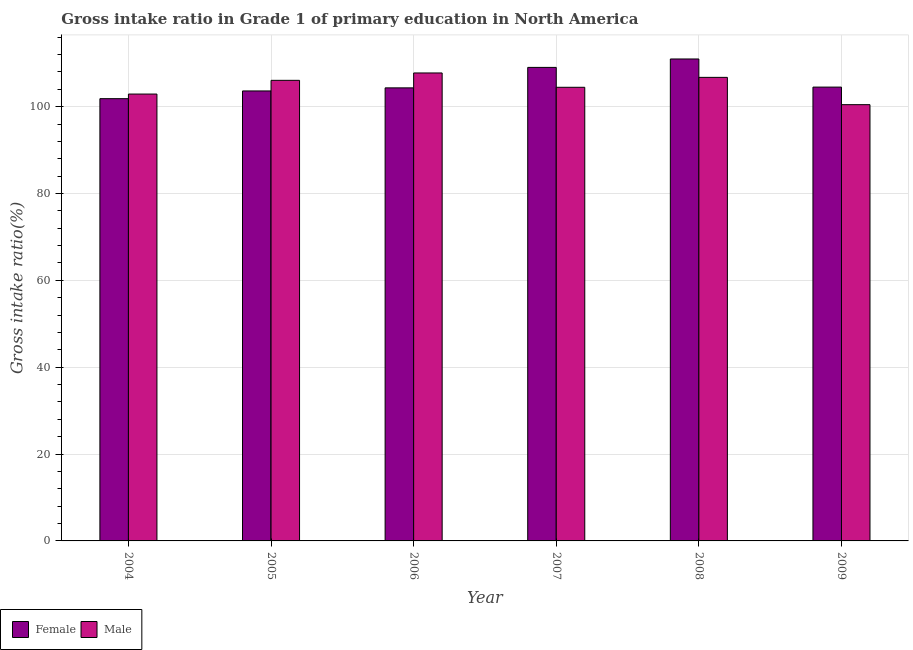Are the number of bars per tick equal to the number of legend labels?
Your answer should be very brief. Yes. Are the number of bars on each tick of the X-axis equal?
Make the answer very short. Yes. How many bars are there on the 6th tick from the left?
Offer a terse response. 2. How many bars are there on the 1st tick from the right?
Your answer should be very brief. 2. What is the gross intake ratio(female) in 2006?
Your answer should be compact. 104.33. Across all years, what is the maximum gross intake ratio(male)?
Provide a succinct answer. 107.76. Across all years, what is the minimum gross intake ratio(male)?
Your answer should be compact. 100.46. In which year was the gross intake ratio(female) minimum?
Make the answer very short. 2004. What is the total gross intake ratio(female) in the graph?
Give a very brief answer. 634.32. What is the difference between the gross intake ratio(female) in 2006 and that in 2007?
Your answer should be very brief. -4.71. What is the difference between the gross intake ratio(male) in 2009 and the gross intake ratio(female) in 2006?
Keep it short and to the point. -7.3. What is the average gross intake ratio(female) per year?
Ensure brevity in your answer.  105.72. In the year 2009, what is the difference between the gross intake ratio(female) and gross intake ratio(male)?
Provide a succinct answer. 0. What is the ratio of the gross intake ratio(female) in 2008 to that in 2009?
Keep it short and to the point. 1.06. Is the gross intake ratio(male) in 2005 less than that in 2008?
Offer a terse response. Yes. Is the difference between the gross intake ratio(male) in 2005 and 2007 greater than the difference between the gross intake ratio(female) in 2005 and 2007?
Make the answer very short. No. What is the difference between the highest and the second highest gross intake ratio(male)?
Offer a terse response. 1.01. What is the difference between the highest and the lowest gross intake ratio(male)?
Ensure brevity in your answer.  7.3. In how many years, is the gross intake ratio(male) greater than the average gross intake ratio(male) taken over all years?
Give a very brief answer. 3. What does the 1st bar from the left in 2008 represents?
Offer a very short reply. Female. What does the 1st bar from the right in 2005 represents?
Your answer should be very brief. Male. How many bars are there?
Offer a terse response. 12. What is the difference between two consecutive major ticks on the Y-axis?
Keep it short and to the point. 20. Are the values on the major ticks of Y-axis written in scientific E-notation?
Your response must be concise. No. Does the graph contain any zero values?
Your answer should be very brief. No. Does the graph contain grids?
Give a very brief answer. Yes. Where does the legend appear in the graph?
Your answer should be compact. Bottom left. How many legend labels are there?
Your answer should be compact. 2. What is the title of the graph?
Provide a short and direct response. Gross intake ratio in Grade 1 of primary education in North America. Does "Services" appear as one of the legend labels in the graph?
Your response must be concise. No. What is the label or title of the Y-axis?
Your answer should be compact. Gross intake ratio(%). What is the Gross intake ratio(%) of Female in 2004?
Make the answer very short. 101.84. What is the Gross intake ratio(%) of Male in 2004?
Offer a terse response. 102.9. What is the Gross intake ratio(%) of Female in 2005?
Provide a short and direct response. 103.62. What is the Gross intake ratio(%) in Male in 2005?
Provide a short and direct response. 106.07. What is the Gross intake ratio(%) of Female in 2006?
Provide a short and direct response. 104.33. What is the Gross intake ratio(%) of Male in 2006?
Your response must be concise. 107.76. What is the Gross intake ratio(%) in Female in 2007?
Offer a terse response. 109.04. What is the Gross intake ratio(%) of Male in 2007?
Your response must be concise. 104.46. What is the Gross intake ratio(%) of Female in 2008?
Ensure brevity in your answer.  110.98. What is the Gross intake ratio(%) in Male in 2008?
Your answer should be compact. 106.75. What is the Gross intake ratio(%) in Female in 2009?
Offer a very short reply. 104.5. What is the Gross intake ratio(%) in Male in 2009?
Provide a short and direct response. 100.46. Across all years, what is the maximum Gross intake ratio(%) in Female?
Provide a succinct answer. 110.98. Across all years, what is the maximum Gross intake ratio(%) of Male?
Your answer should be compact. 107.76. Across all years, what is the minimum Gross intake ratio(%) in Female?
Give a very brief answer. 101.84. Across all years, what is the minimum Gross intake ratio(%) of Male?
Your response must be concise. 100.46. What is the total Gross intake ratio(%) in Female in the graph?
Your answer should be compact. 634.32. What is the total Gross intake ratio(%) of Male in the graph?
Offer a terse response. 628.4. What is the difference between the Gross intake ratio(%) of Female in 2004 and that in 2005?
Provide a succinct answer. -1.78. What is the difference between the Gross intake ratio(%) of Male in 2004 and that in 2005?
Ensure brevity in your answer.  -3.16. What is the difference between the Gross intake ratio(%) in Female in 2004 and that in 2006?
Give a very brief answer. -2.49. What is the difference between the Gross intake ratio(%) in Male in 2004 and that in 2006?
Offer a very short reply. -4.86. What is the difference between the Gross intake ratio(%) in Female in 2004 and that in 2007?
Provide a short and direct response. -7.2. What is the difference between the Gross intake ratio(%) of Male in 2004 and that in 2007?
Provide a short and direct response. -1.56. What is the difference between the Gross intake ratio(%) in Female in 2004 and that in 2008?
Offer a terse response. -9.14. What is the difference between the Gross intake ratio(%) of Male in 2004 and that in 2008?
Provide a short and direct response. -3.84. What is the difference between the Gross intake ratio(%) of Female in 2004 and that in 2009?
Offer a terse response. -2.66. What is the difference between the Gross intake ratio(%) in Male in 2004 and that in 2009?
Provide a short and direct response. 2.44. What is the difference between the Gross intake ratio(%) in Female in 2005 and that in 2006?
Your answer should be very brief. -0.71. What is the difference between the Gross intake ratio(%) in Male in 2005 and that in 2006?
Make the answer very short. -1.7. What is the difference between the Gross intake ratio(%) in Female in 2005 and that in 2007?
Make the answer very short. -5.42. What is the difference between the Gross intake ratio(%) of Male in 2005 and that in 2007?
Your response must be concise. 1.6. What is the difference between the Gross intake ratio(%) of Female in 2005 and that in 2008?
Give a very brief answer. -7.36. What is the difference between the Gross intake ratio(%) in Male in 2005 and that in 2008?
Keep it short and to the point. -0.68. What is the difference between the Gross intake ratio(%) in Female in 2005 and that in 2009?
Provide a short and direct response. -0.88. What is the difference between the Gross intake ratio(%) of Male in 2005 and that in 2009?
Your answer should be compact. 5.6. What is the difference between the Gross intake ratio(%) of Female in 2006 and that in 2007?
Your answer should be very brief. -4.71. What is the difference between the Gross intake ratio(%) of Male in 2006 and that in 2007?
Offer a terse response. 3.3. What is the difference between the Gross intake ratio(%) in Female in 2006 and that in 2008?
Make the answer very short. -6.65. What is the difference between the Gross intake ratio(%) of Male in 2006 and that in 2008?
Offer a very short reply. 1.01. What is the difference between the Gross intake ratio(%) in Female in 2006 and that in 2009?
Offer a very short reply. -0.17. What is the difference between the Gross intake ratio(%) of Male in 2006 and that in 2009?
Give a very brief answer. 7.3. What is the difference between the Gross intake ratio(%) of Female in 2007 and that in 2008?
Provide a short and direct response. -1.94. What is the difference between the Gross intake ratio(%) in Male in 2007 and that in 2008?
Provide a succinct answer. -2.29. What is the difference between the Gross intake ratio(%) of Female in 2007 and that in 2009?
Offer a very short reply. 4.54. What is the difference between the Gross intake ratio(%) in Male in 2007 and that in 2009?
Make the answer very short. 4. What is the difference between the Gross intake ratio(%) in Female in 2008 and that in 2009?
Offer a very short reply. 6.48. What is the difference between the Gross intake ratio(%) in Male in 2008 and that in 2009?
Offer a terse response. 6.29. What is the difference between the Gross intake ratio(%) in Female in 2004 and the Gross intake ratio(%) in Male in 2005?
Keep it short and to the point. -4.22. What is the difference between the Gross intake ratio(%) of Female in 2004 and the Gross intake ratio(%) of Male in 2006?
Give a very brief answer. -5.92. What is the difference between the Gross intake ratio(%) of Female in 2004 and the Gross intake ratio(%) of Male in 2007?
Offer a very short reply. -2.62. What is the difference between the Gross intake ratio(%) of Female in 2004 and the Gross intake ratio(%) of Male in 2008?
Your response must be concise. -4.91. What is the difference between the Gross intake ratio(%) in Female in 2004 and the Gross intake ratio(%) in Male in 2009?
Offer a terse response. 1.38. What is the difference between the Gross intake ratio(%) of Female in 2005 and the Gross intake ratio(%) of Male in 2006?
Your answer should be compact. -4.14. What is the difference between the Gross intake ratio(%) in Female in 2005 and the Gross intake ratio(%) in Male in 2007?
Your answer should be very brief. -0.84. What is the difference between the Gross intake ratio(%) in Female in 2005 and the Gross intake ratio(%) in Male in 2008?
Your answer should be very brief. -3.13. What is the difference between the Gross intake ratio(%) of Female in 2005 and the Gross intake ratio(%) of Male in 2009?
Ensure brevity in your answer.  3.16. What is the difference between the Gross intake ratio(%) in Female in 2006 and the Gross intake ratio(%) in Male in 2007?
Provide a short and direct response. -0.13. What is the difference between the Gross intake ratio(%) in Female in 2006 and the Gross intake ratio(%) in Male in 2008?
Your response must be concise. -2.42. What is the difference between the Gross intake ratio(%) in Female in 2006 and the Gross intake ratio(%) in Male in 2009?
Offer a very short reply. 3.87. What is the difference between the Gross intake ratio(%) in Female in 2007 and the Gross intake ratio(%) in Male in 2008?
Offer a terse response. 2.29. What is the difference between the Gross intake ratio(%) in Female in 2007 and the Gross intake ratio(%) in Male in 2009?
Your answer should be very brief. 8.58. What is the difference between the Gross intake ratio(%) in Female in 2008 and the Gross intake ratio(%) in Male in 2009?
Give a very brief answer. 10.52. What is the average Gross intake ratio(%) in Female per year?
Your answer should be compact. 105.72. What is the average Gross intake ratio(%) of Male per year?
Your answer should be very brief. 104.73. In the year 2004, what is the difference between the Gross intake ratio(%) in Female and Gross intake ratio(%) in Male?
Your response must be concise. -1.06. In the year 2005, what is the difference between the Gross intake ratio(%) in Female and Gross intake ratio(%) in Male?
Ensure brevity in your answer.  -2.44. In the year 2006, what is the difference between the Gross intake ratio(%) in Female and Gross intake ratio(%) in Male?
Offer a terse response. -3.43. In the year 2007, what is the difference between the Gross intake ratio(%) of Female and Gross intake ratio(%) of Male?
Offer a very short reply. 4.58. In the year 2008, what is the difference between the Gross intake ratio(%) of Female and Gross intake ratio(%) of Male?
Offer a very short reply. 4.24. In the year 2009, what is the difference between the Gross intake ratio(%) in Female and Gross intake ratio(%) in Male?
Keep it short and to the point. 4.04. What is the ratio of the Gross intake ratio(%) in Female in 2004 to that in 2005?
Ensure brevity in your answer.  0.98. What is the ratio of the Gross intake ratio(%) of Male in 2004 to that in 2005?
Make the answer very short. 0.97. What is the ratio of the Gross intake ratio(%) of Female in 2004 to that in 2006?
Provide a short and direct response. 0.98. What is the ratio of the Gross intake ratio(%) of Male in 2004 to that in 2006?
Your response must be concise. 0.95. What is the ratio of the Gross intake ratio(%) in Female in 2004 to that in 2007?
Your answer should be compact. 0.93. What is the ratio of the Gross intake ratio(%) in Male in 2004 to that in 2007?
Ensure brevity in your answer.  0.99. What is the ratio of the Gross intake ratio(%) in Female in 2004 to that in 2008?
Provide a short and direct response. 0.92. What is the ratio of the Gross intake ratio(%) of Male in 2004 to that in 2008?
Give a very brief answer. 0.96. What is the ratio of the Gross intake ratio(%) of Female in 2004 to that in 2009?
Give a very brief answer. 0.97. What is the ratio of the Gross intake ratio(%) in Male in 2004 to that in 2009?
Your answer should be very brief. 1.02. What is the ratio of the Gross intake ratio(%) of Male in 2005 to that in 2006?
Your answer should be very brief. 0.98. What is the ratio of the Gross intake ratio(%) in Female in 2005 to that in 2007?
Make the answer very short. 0.95. What is the ratio of the Gross intake ratio(%) in Male in 2005 to that in 2007?
Your answer should be very brief. 1.02. What is the ratio of the Gross intake ratio(%) in Female in 2005 to that in 2008?
Your answer should be very brief. 0.93. What is the ratio of the Gross intake ratio(%) in Male in 2005 to that in 2008?
Provide a succinct answer. 0.99. What is the ratio of the Gross intake ratio(%) of Female in 2005 to that in 2009?
Make the answer very short. 0.99. What is the ratio of the Gross intake ratio(%) of Male in 2005 to that in 2009?
Your answer should be very brief. 1.06. What is the ratio of the Gross intake ratio(%) in Female in 2006 to that in 2007?
Offer a terse response. 0.96. What is the ratio of the Gross intake ratio(%) in Male in 2006 to that in 2007?
Your answer should be very brief. 1.03. What is the ratio of the Gross intake ratio(%) in Female in 2006 to that in 2008?
Give a very brief answer. 0.94. What is the ratio of the Gross intake ratio(%) in Male in 2006 to that in 2008?
Give a very brief answer. 1.01. What is the ratio of the Gross intake ratio(%) in Male in 2006 to that in 2009?
Keep it short and to the point. 1.07. What is the ratio of the Gross intake ratio(%) in Female in 2007 to that in 2008?
Your answer should be very brief. 0.98. What is the ratio of the Gross intake ratio(%) of Male in 2007 to that in 2008?
Offer a very short reply. 0.98. What is the ratio of the Gross intake ratio(%) in Female in 2007 to that in 2009?
Offer a terse response. 1.04. What is the ratio of the Gross intake ratio(%) of Male in 2007 to that in 2009?
Your answer should be compact. 1.04. What is the ratio of the Gross intake ratio(%) in Female in 2008 to that in 2009?
Offer a very short reply. 1.06. What is the ratio of the Gross intake ratio(%) in Male in 2008 to that in 2009?
Provide a short and direct response. 1.06. What is the difference between the highest and the second highest Gross intake ratio(%) of Female?
Provide a short and direct response. 1.94. What is the difference between the highest and the second highest Gross intake ratio(%) of Male?
Provide a short and direct response. 1.01. What is the difference between the highest and the lowest Gross intake ratio(%) in Female?
Your answer should be compact. 9.14. What is the difference between the highest and the lowest Gross intake ratio(%) of Male?
Provide a succinct answer. 7.3. 